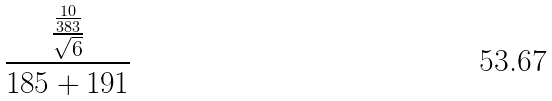<formula> <loc_0><loc_0><loc_500><loc_500>\frac { \frac { \frac { 1 0 } { 3 8 3 } } { \sqrt { 6 } } } { 1 8 5 + 1 9 1 }</formula> 